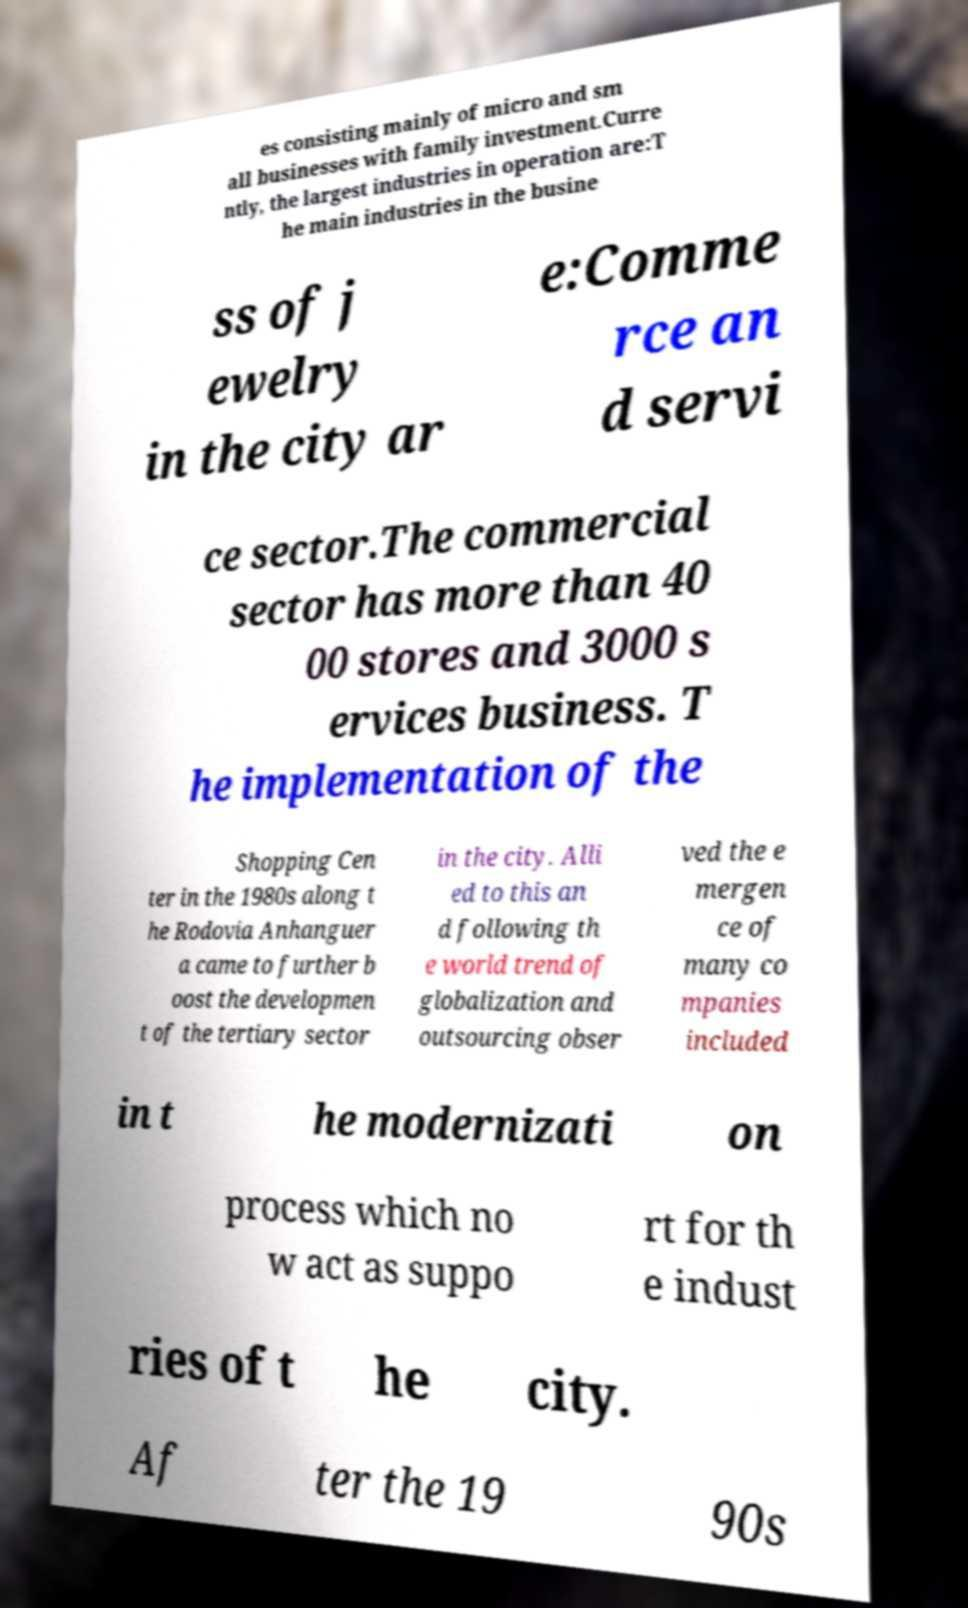Please read and relay the text visible in this image. What does it say? es consisting mainly of micro and sm all businesses with family investment.Curre ntly, the largest industries in operation are:T he main industries in the busine ss of j ewelry in the city ar e:Comme rce an d servi ce sector.The commercial sector has more than 40 00 stores and 3000 s ervices business. T he implementation of the Shopping Cen ter in the 1980s along t he Rodovia Anhanguer a came to further b oost the developmen t of the tertiary sector in the city. Alli ed to this an d following th e world trend of globalization and outsourcing obser ved the e mergen ce of many co mpanies included in t he modernizati on process which no w act as suppo rt for th e indust ries of t he city. Af ter the 19 90s 